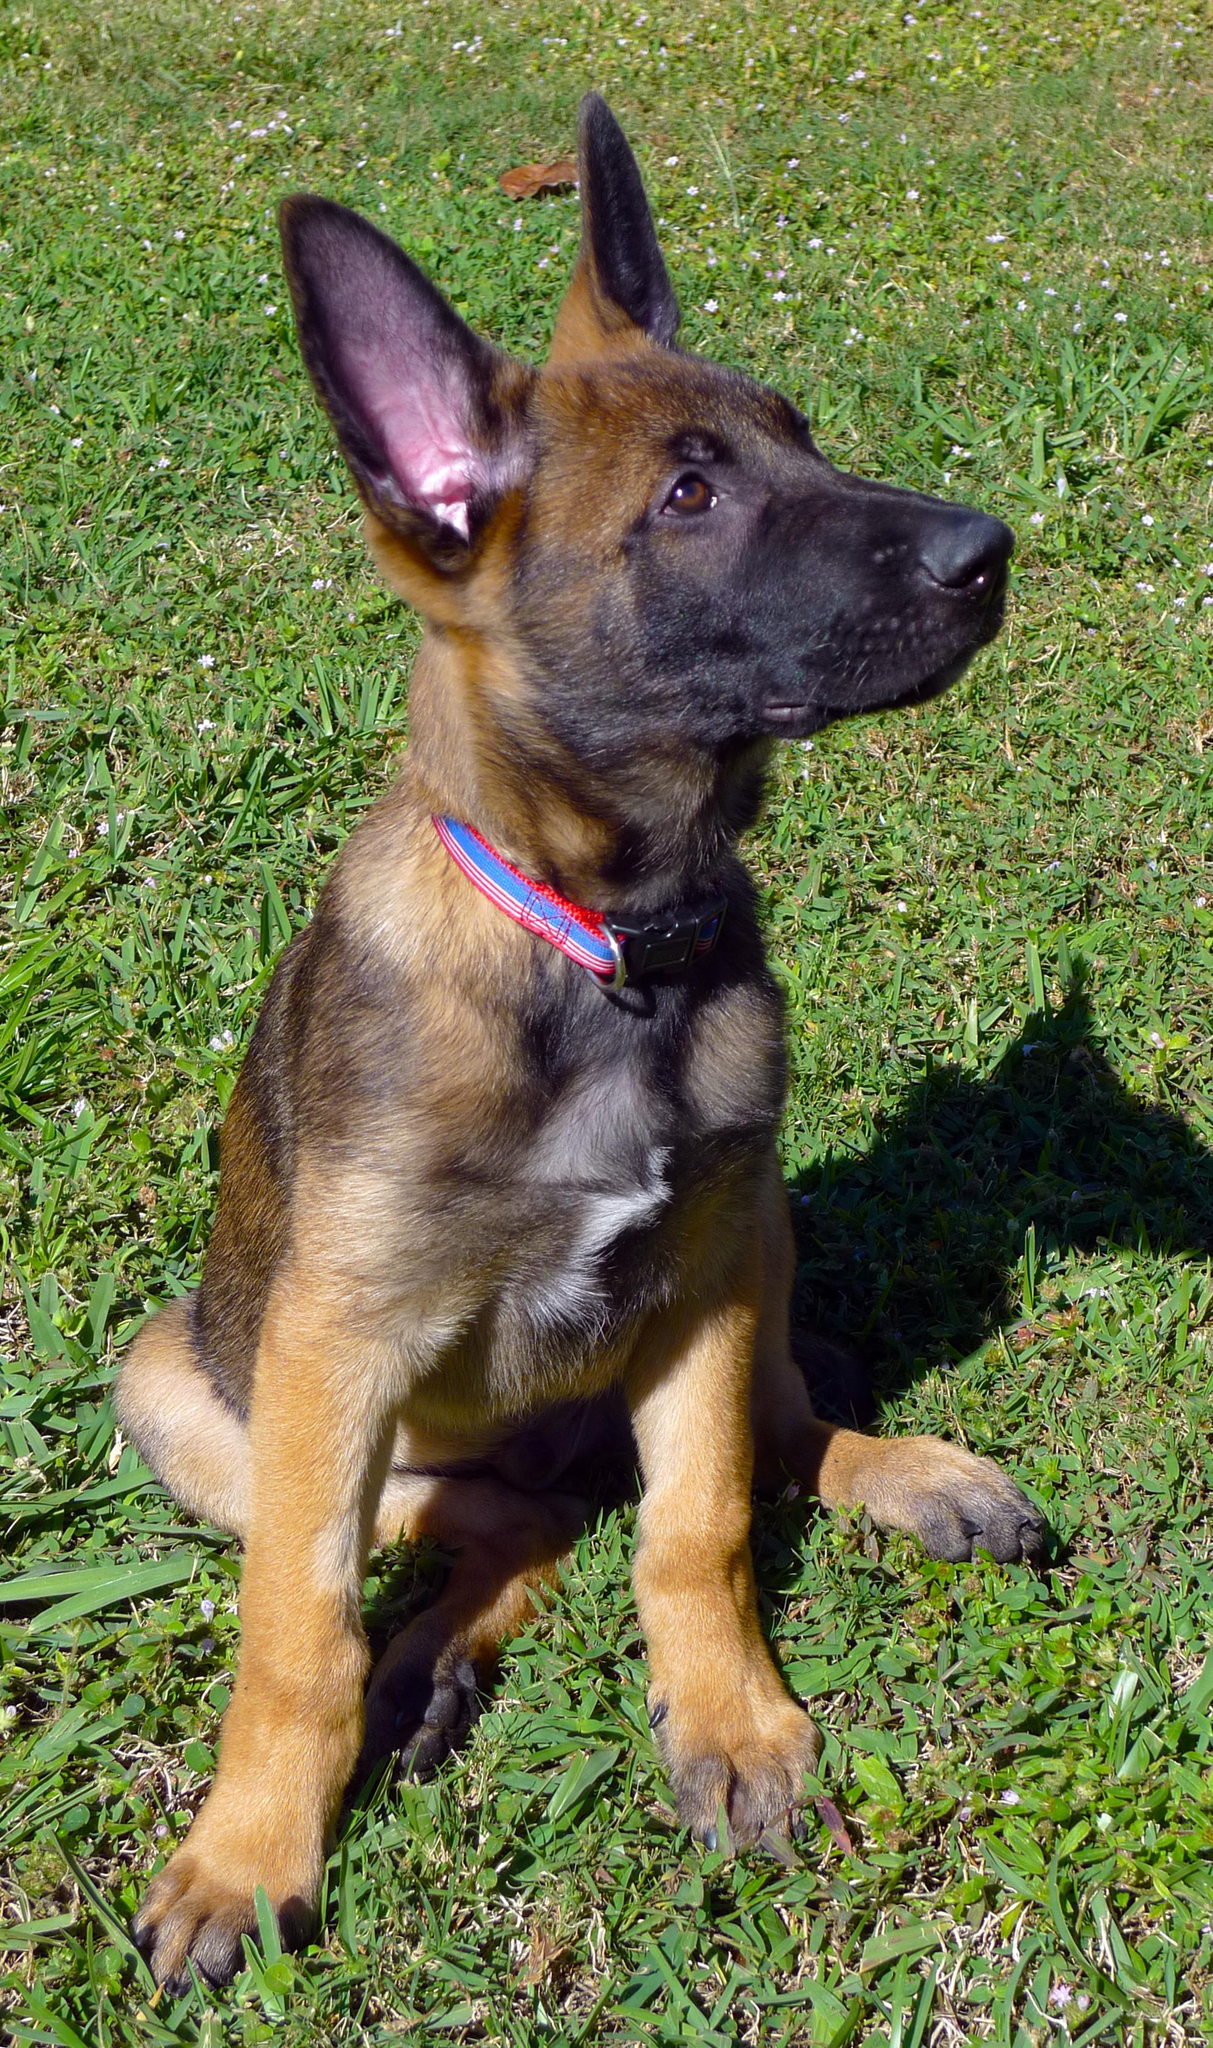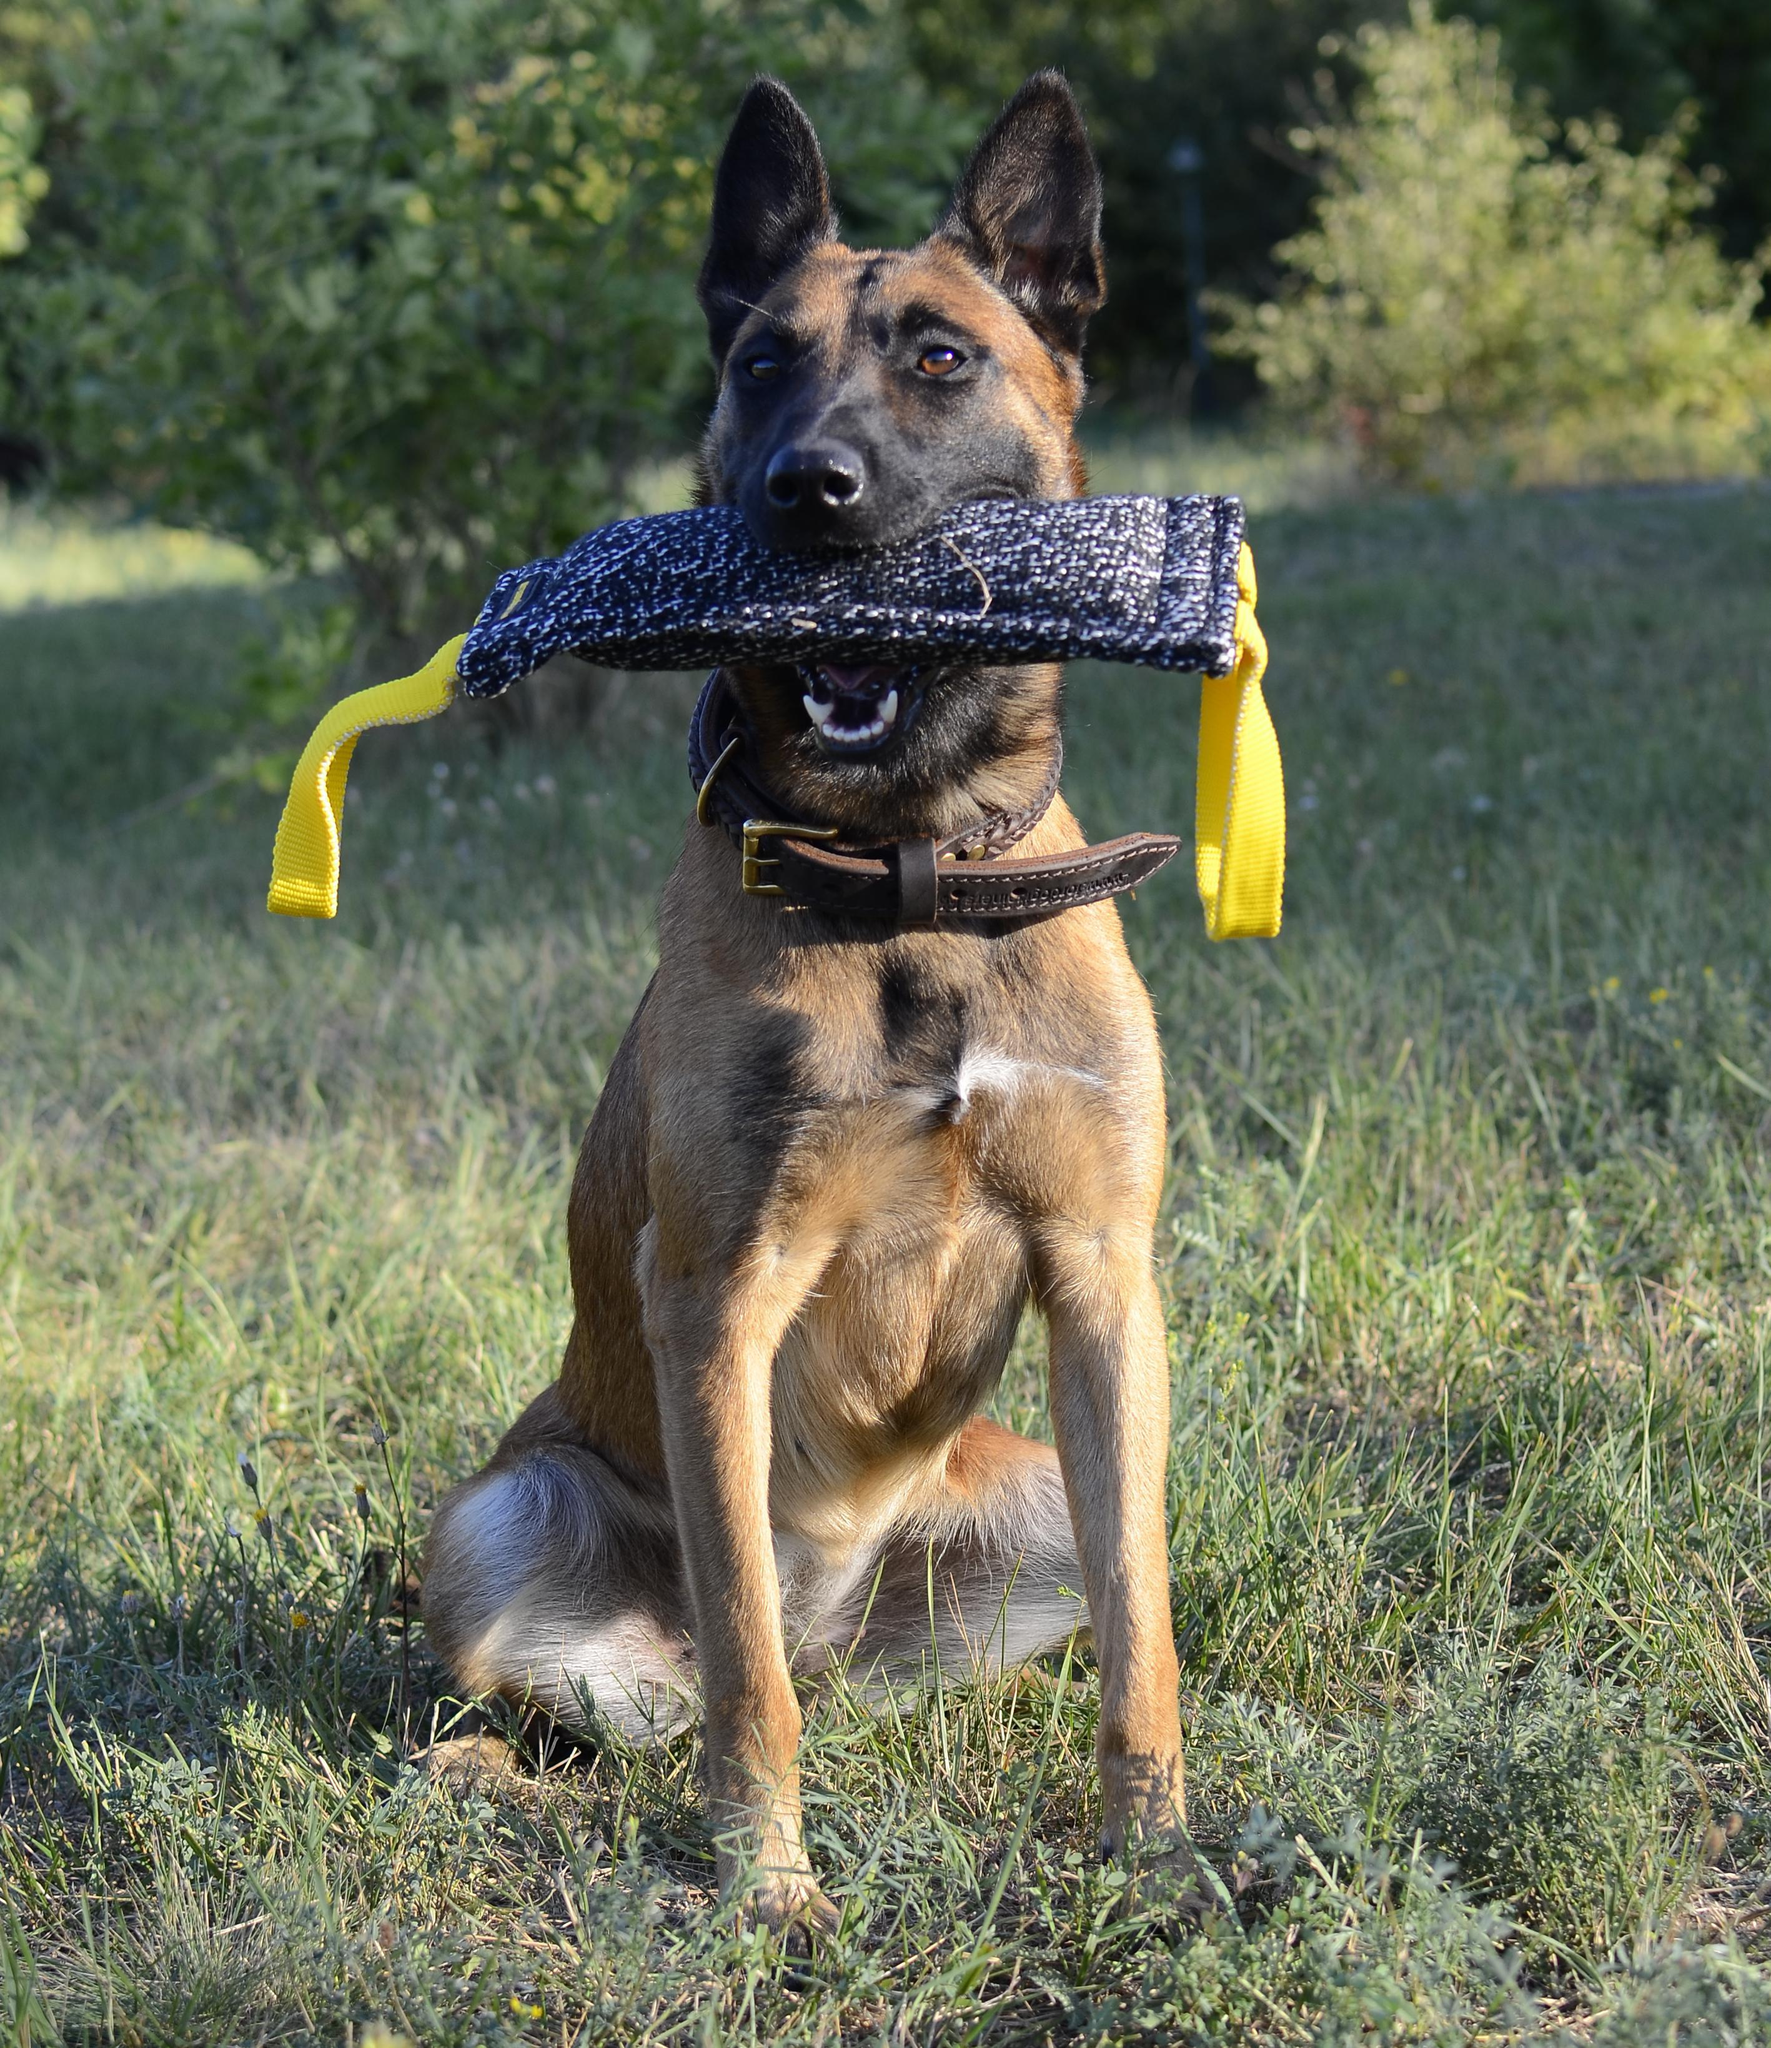The first image is the image on the left, the second image is the image on the right. Analyze the images presented: Is the assertion "An image shows someone wearing jeans standing behind a german shepherd dog." valid? Answer yes or no. No. The first image is the image on the left, the second image is the image on the right. Given the left and right images, does the statement "The dog in the image on the right is lying in a grassy area." hold true? Answer yes or no. No. 